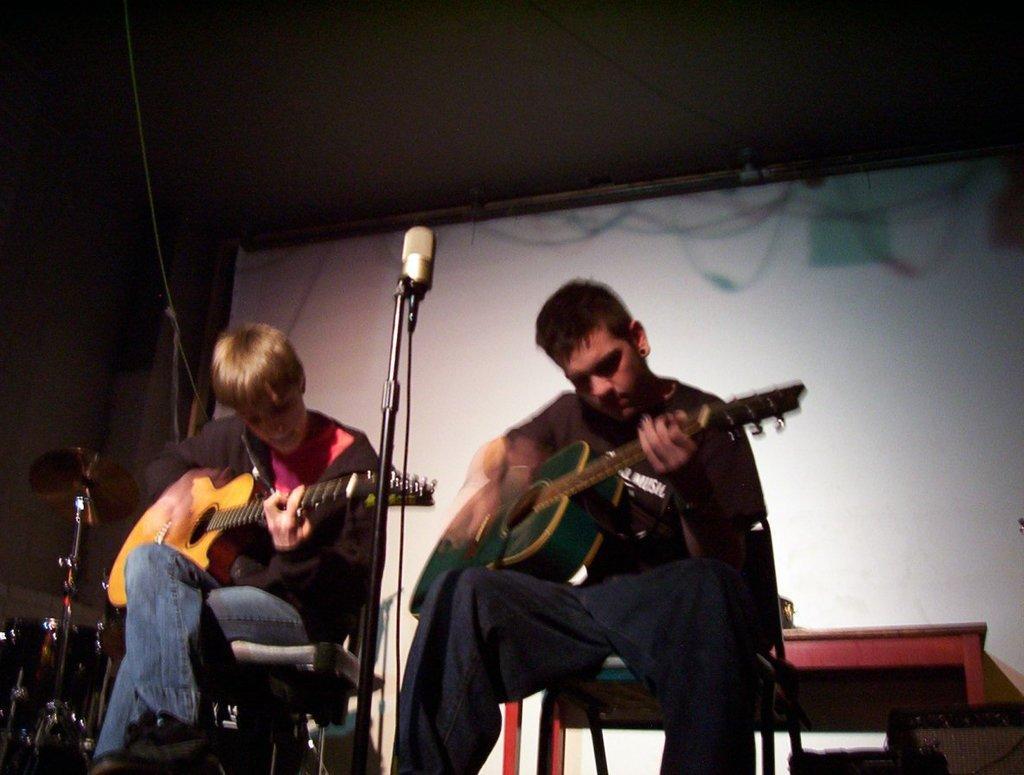Describe this image in one or two sentences. These two persons sitting and holding guitar. There is a microphone with stand. On the background we can see banner. There is a musical instrument. 